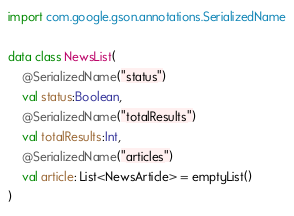Convert code to text. <code><loc_0><loc_0><loc_500><loc_500><_Kotlin_>
import com.google.gson.annotations.SerializedName

data class NewsList(
    @SerializedName("status")
    val status:Boolean,
    @SerializedName("totalResults")
    val totalResults:Int,
    @SerializedName("articles")
    val article: List<NewsArticle> = emptyList()
)</code> 